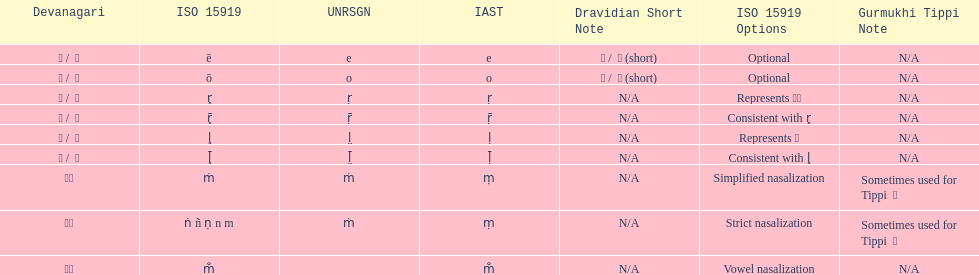Which devanagaria means the same as this iast letter: o? ओ / ो. 